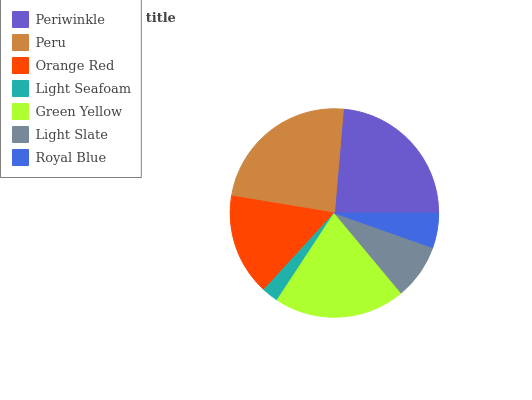Is Light Seafoam the minimum?
Answer yes or no. Yes. Is Peru the maximum?
Answer yes or no. Yes. Is Orange Red the minimum?
Answer yes or no. No. Is Orange Red the maximum?
Answer yes or no. No. Is Peru greater than Orange Red?
Answer yes or no. Yes. Is Orange Red less than Peru?
Answer yes or no. Yes. Is Orange Red greater than Peru?
Answer yes or no. No. Is Peru less than Orange Red?
Answer yes or no. No. Is Orange Red the high median?
Answer yes or no. Yes. Is Orange Red the low median?
Answer yes or no. Yes. Is Royal Blue the high median?
Answer yes or no. No. Is Periwinkle the low median?
Answer yes or no. No. 